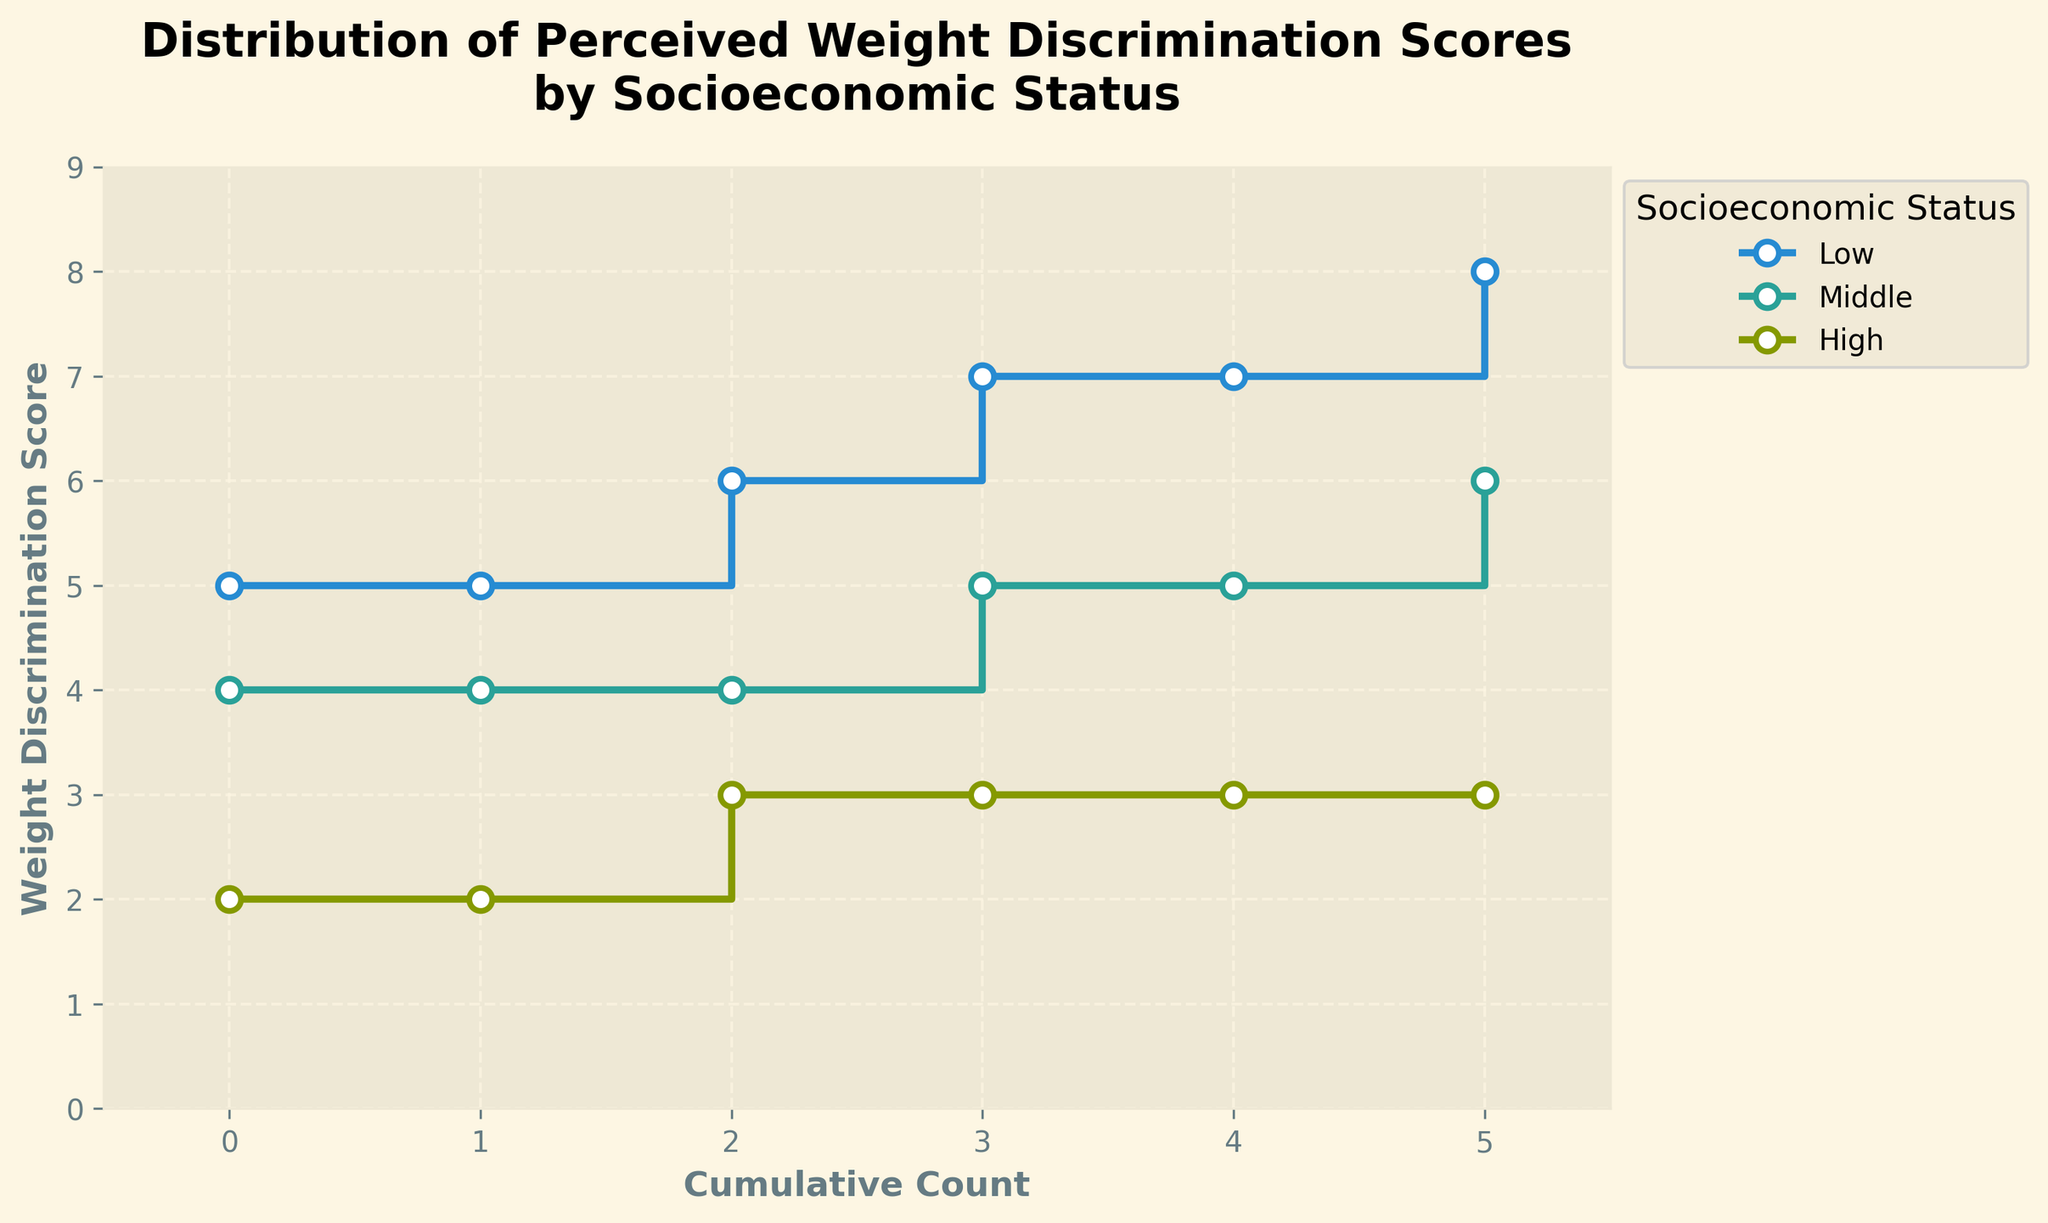What's the title of the plot? The title of the plot is located at the top and describes the main purpose of the visualization.
Answer: Distribution of Perceived Weight Discrimination Scores by Socioeconomic Status What is the range of Weight Discrimination Scores for the 'High' socioeconomic status group? To find the range, identify the minimum and maximum scores for the 'High' socioeconomic status, which are 2 and 3 respectively.
Answer: 2 to 3 Which socioeconomic status group has the highest maximum Weight Discrimination Score? By examining the step lines in the plot, the 'Low' socioeconomic status group reaches the highest value, which is 8.
Answer: Low How many different Weight Discrimination Scores are observed in the 'Middle' group? Count the unique tick points along the step line corresponding to the 'Middle' socioeconomic status. The observed scores are 4, 5, and 6.
Answer: 3 What is the median Weight Discrimination Score for the 'Low' socioeconomic status? For the 'Low' socioeconomic status, list all scores (5, 5, 6, 7, 7, 8) in ascending order. The median is the middle value, which is the average of the two central numbers, (6 + 7) / 2.
Answer: 6.5 Is the variation in Weight Discrimination Scores higher for the 'Low' group compared to the 'High' group? The 'Low' group's scores range from 5 to 8, providing a wider variation compared to the 'High' group whose scores range from 2 to 3. Therefore, the 'Low' group shows higher variation.
Answer: Yes Which socioeconomic status group has the lowest minimum Weight Discrimination Score? By checking the step lines on the plot, the 'High' group reaches the lowest minimum score, which is 2.
Answer: High What's the average Weight Discrimination Score for the 'Middle' socioeconomic status group? Sum the scores for the 'Middle' group (4, 4, 4, 5, 5, 6) and divide by the total number of data points (6). The sum is 28, so the average is 28 / 6.
Answer: 4.67 How does the 'Low' socioeconomic status group's highest score compare to the 'High' group's highest score? The highest score for the 'Low' group is 8, and for the 'High' group it's 3. Thus, the 'Low' group's highest score is greater.
Answer: Low > High What is the general trend of Weight Discrimination Scores across socioeconomic status groups? From the plot, scores tend to decrease as socioeconomic status increases; the 'Low' group generally has higher scores, the 'Middle' group has intermediate scores, and the 'High' group has the lowest scores.
Answer: Decrease with increasing socioeconomic status 